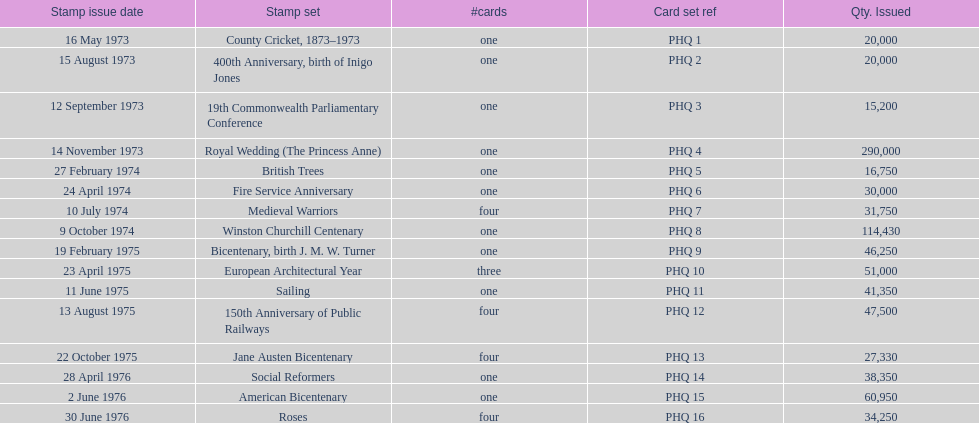How many stamp sets had at least 50,000 issued? 4. 